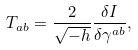<formula> <loc_0><loc_0><loc_500><loc_500>T _ { a b } = \frac { 2 } { \sqrt { - h } } \frac { \delta I } { \delta \gamma ^ { a b } } ,</formula> 